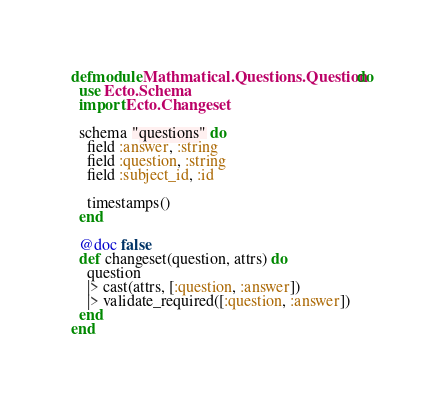<code> <loc_0><loc_0><loc_500><loc_500><_Elixir_>defmodule Mathmatical.Questions.Question do
  use Ecto.Schema
  import Ecto.Changeset

  schema "questions" do
    field :answer, :string
    field :question, :string
    field :subject_id, :id

    timestamps()
  end

  @doc false
  def changeset(question, attrs) do
    question
    |> cast(attrs, [:question, :answer])
    |> validate_required([:question, :answer])
  end
end
</code> 